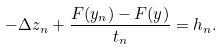<formula> <loc_0><loc_0><loc_500><loc_500>- \Delta z _ { n } + \frac { F ( y _ { n } ) - F ( y ) } { t _ { n } } = h _ { n } .</formula> 